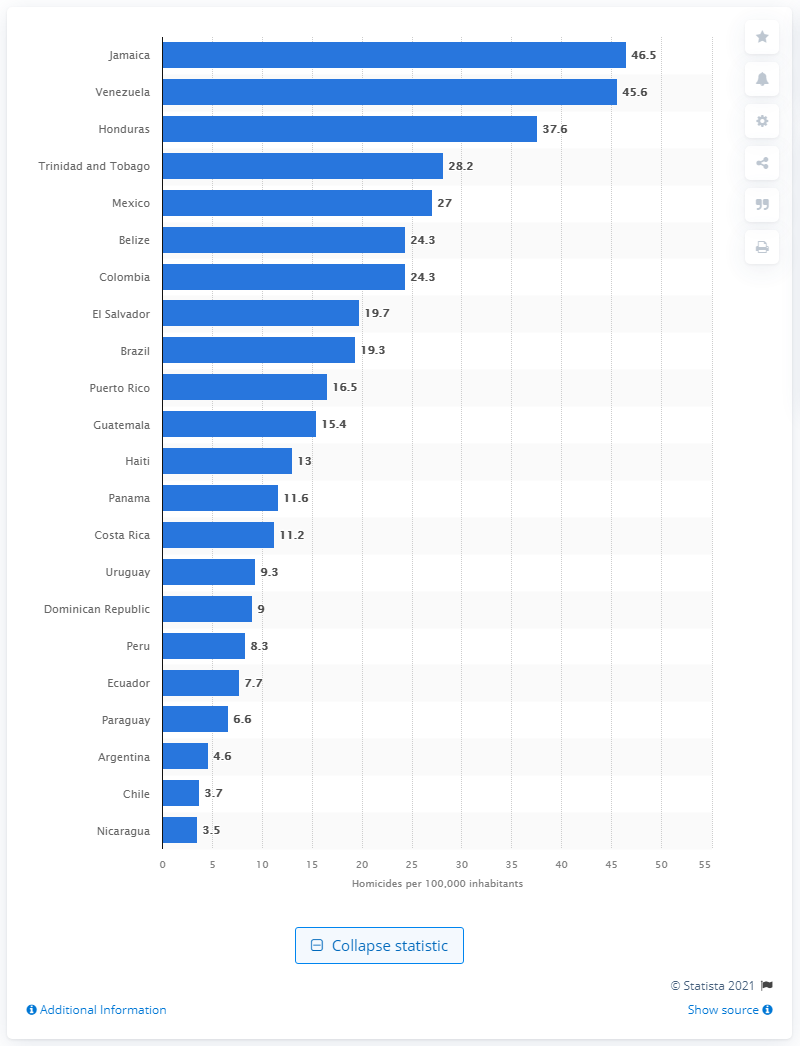Identify some key points in this picture. In 2020, Venezuela had a homicide rate of 45.6 per 100,000 people. Nicaragua had the lowest homicide rate in 2020 among all countries. In 2020, Jamaica had the highest homicide rate among all countries. Honduras ranked third in homicide rates in 2020, according to recent data. 